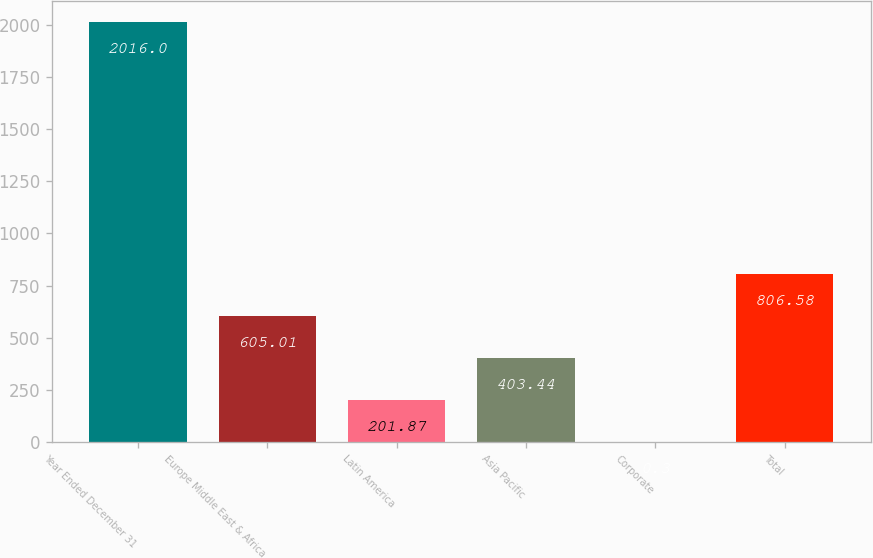Convert chart to OTSL. <chart><loc_0><loc_0><loc_500><loc_500><bar_chart><fcel>Year Ended December 31<fcel>Europe Middle East & Africa<fcel>Latin America<fcel>Asia Pacific<fcel>Corporate<fcel>Total<nl><fcel>2016<fcel>605.01<fcel>201.87<fcel>403.44<fcel>0.3<fcel>806.58<nl></chart> 